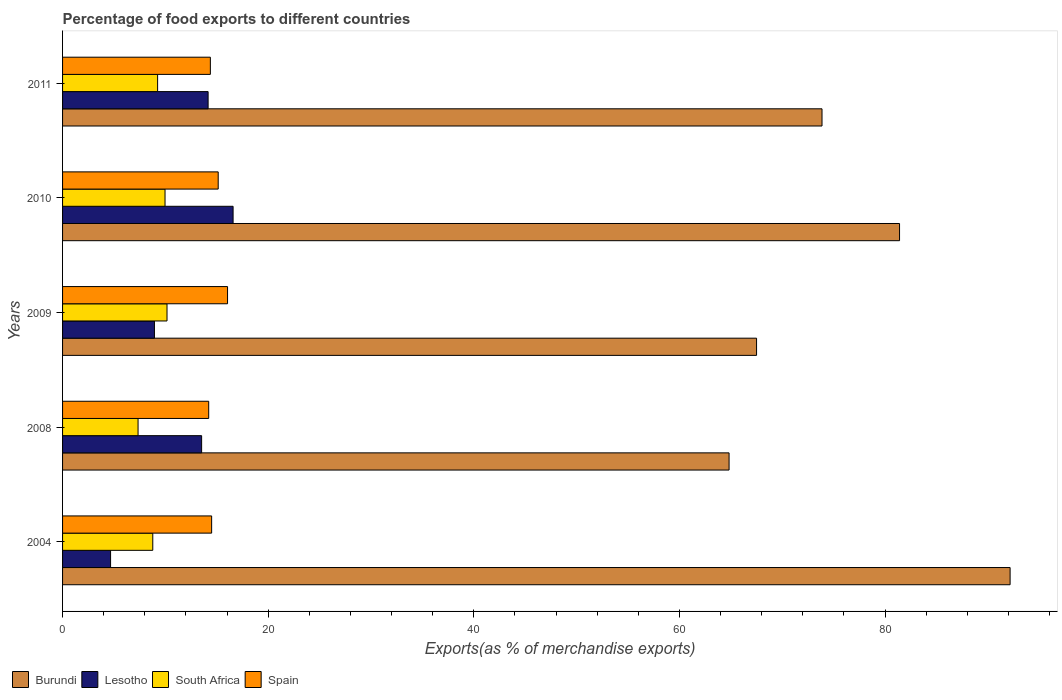How many different coloured bars are there?
Ensure brevity in your answer.  4. How many groups of bars are there?
Your response must be concise. 5. Are the number of bars per tick equal to the number of legend labels?
Give a very brief answer. Yes. Are the number of bars on each tick of the Y-axis equal?
Provide a short and direct response. Yes. How many bars are there on the 2nd tick from the top?
Provide a succinct answer. 4. What is the percentage of exports to different countries in South Africa in 2009?
Your response must be concise. 10.16. Across all years, what is the maximum percentage of exports to different countries in Burundi?
Ensure brevity in your answer.  92.16. Across all years, what is the minimum percentage of exports to different countries in Lesotho?
Your answer should be very brief. 4.67. In which year was the percentage of exports to different countries in Lesotho maximum?
Provide a succinct answer. 2010. In which year was the percentage of exports to different countries in Burundi minimum?
Keep it short and to the point. 2008. What is the total percentage of exports to different countries in Lesotho in the graph?
Give a very brief answer. 57.87. What is the difference between the percentage of exports to different countries in Lesotho in 2004 and that in 2009?
Make the answer very short. -4.27. What is the difference between the percentage of exports to different countries in Spain in 2004 and the percentage of exports to different countries in Burundi in 2008?
Keep it short and to the point. -50.33. What is the average percentage of exports to different countries in South Africa per year?
Offer a terse response. 9.1. In the year 2009, what is the difference between the percentage of exports to different countries in South Africa and percentage of exports to different countries in Lesotho?
Offer a terse response. 1.22. What is the ratio of the percentage of exports to different countries in South Africa in 2010 to that in 2011?
Make the answer very short. 1.08. Is the difference between the percentage of exports to different countries in South Africa in 2010 and 2011 greater than the difference between the percentage of exports to different countries in Lesotho in 2010 and 2011?
Provide a succinct answer. No. What is the difference between the highest and the second highest percentage of exports to different countries in Burundi?
Your answer should be compact. 10.75. What is the difference between the highest and the lowest percentage of exports to different countries in Spain?
Provide a succinct answer. 1.83. Is the sum of the percentage of exports to different countries in South Africa in 2004 and 2009 greater than the maximum percentage of exports to different countries in Burundi across all years?
Your answer should be very brief. No. What does the 2nd bar from the top in 2008 represents?
Give a very brief answer. South Africa. What does the 1st bar from the bottom in 2009 represents?
Ensure brevity in your answer.  Burundi. Is it the case that in every year, the sum of the percentage of exports to different countries in Lesotho and percentage of exports to different countries in Spain is greater than the percentage of exports to different countries in Burundi?
Keep it short and to the point. No. Are all the bars in the graph horizontal?
Give a very brief answer. Yes. How many years are there in the graph?
Ensure brevity in your answer.  5. Are the values on the major ticks of X-axis written in scientific E-notation?
Offer a terse response. No. Does the graph contain any zero values?
Make the answer very short. No. Does the graph contain grids?
Provide a short and direct response. No. How many legend labels are there?
Provide a short and direct response. 4. What is the title of the graph?
Your answer should be compact. Percentage of food exports to different countries. What is the label or title of the X-axis?
Your answer should be very brief. Exports(as % of merchandise exports). What is the Exports(as % of merchandise exports) of Burundi in 2004?
Provide a succinct answer. 92.16. What is the Exports(as % of merchandise exports) of Lesotho in 2004?
Offer a terse response. 4.67. What is the Exports(as % of merchandise exports) in South Africa in 2004?
Your response must be concise. 8.77. What is the Exports(as % of merchandise exports) of Spain in 2004?
Your answer should be very brief. 14.5. What is the Exports(as % of merchandise exports) in Burundi in 2008?
Ensure brevity in your answer.  64.83. What is the Exports(as % of merchandise exports) of Lesotho in 2008?
Keep it short and to the point. 13.52. What is the Exports(as % of merchandise exports) of South Africa in 2008?
Keep it short and to the point. 7.34. What is the Exports(as % of merchandise exports) of Spain in 2008?
Offer a very short reply. 14.21. What is the Exports(as % of merchandise exports) in Burundi in 2009?
Your response must be concise. 67.5. What is the Exports(as % of merchandise exports) of Lesotho in 2009?
Keep it short and to the point. 8.93. What is the Exports(as % of merchandise exports) in South Africa in 2009?
Ensure brevity in your answer.  10.16. What is the Exports(as % of merchandise exports) of Spain in 2009?
Keep it short and to the point. 16.05. What is the Exports(as % of merchandise exports) in Burundi in 2010?
Ensure brevity in your answer.  81.41. What is the Exports(as % of merchandise exports) of Lesotho in 2010?
Ensure brevity in your answer.  16.59. What is the Exports(as % of merchandise exports) in South Africa in 2010?
Ensure brevity in your answer.  9.97. What is the Exports(as % of merchandise exports) in Spain in 2010?
Provide a succinct answer. 15.14. What is the Exports(as % of merchandise exports) of Burundi in 2011?
Ensure brevity in your answer.  73.87. What is the Exports(as % of merchandise exports) of Lesotho in 2011?
Make the answer very short. 14.16. What is the Exports(as % of merchandise exports) in South Africa in 2011?
Your answer should be compact. 9.24. What is the Exports(as % of merchandise exports) of Spain in 2011?
Your response must be concise. 14.37. Across all years, what is the maximum Exports(as % of merchandise exports) in Burundi?
Make the answer very short. 92.16. Across all years, what is the maximum Exports(as % of merchandise exports) of Lesotho?
Ensure brevity in your answer.  16.59. Across all years, what is the maximum Exports(as % of merchandise exports) of South Africa?
Offer a very short reply. 10.16. Across all years, what is the maximum Exports(as % of merchandise exports) in Spain?
Your answer should be very brief. 16.05. Across all years, what is the minimum Exports(as % of merchandise exports) of Burundi?
Keep it short and to the point. 64.83. Across all years, what is the minimum Exports(as % of merchandise exports) of Lesotho?
Offer a terse response. 4.67. Across all years, what is the minimum Exports(as % of merchandise exports) of South Africa?
Your answer should be compact. 7.34. Across all years, what is the minimum Exports(as % of merchandise exports) of Spain?
Your response must be concise. 14.21. What is the total Exports(as % of merchandise exports) in Burundi in the graph?
Keep it short and to the point. 379.75. What is the total Exports(as % of merchandise exports) in Lesotho in the graph?
Provide a succinct answer. 57.87. What is the total Exports(as % of merchandise exports) of South Africa in the graph?
Keep it short and to the point. 45.49. What is the total Exports(as % of merchandise exports) of Spain in the graph?
Offer a terse response. 74.27. What is the difference between the Exports(as % of merchandise exports) of Burundi in 2004 and that in 2008?
Give a very brief answer. 27.33. What is the difference between the Exports(as % of merchandise exports) in Lesotho in 2004 and that in 2008?
Your answer should be very brief. -8.85. What is the difference between the Exports(as % of merchandise exports) of South Africa in 2004 and that in 2008?
Ensure brevity in your answer.  1.43. What is the difference between the Exports(as % of merchandise exports) of Spain in 2004 and that in 2008?
Make the answer very short. 0.29. What is the difference between the Exports(as % of merchandise exports) in Burundi in 2004 and that in 2009?
Your response must be concise. 24.66. What is the difference between the Exports(as % of merchandise exports) in Lesotho in 2004 and that in 2009?
Provide a short and direct response. -4.27. What is the difference between the Exports(as % of merchandise exports) of South Africa in 2004 and that in 2009?
Give a very brief answer. -1.38. What is the difference between the Exports(as % of merchandise exports) in Spain in 2004 and that in 2009?
Give a very brief answer. -1.55. What is the difference between the Exports(as % of merchandise exports) of Burundi in 2004 and that in 2010?
Your answer should be very brief. 10.75. What is the difference between the Exports(as % of merchandise exports) of Lesotho in 2004 and that in 2010?
Ensure brevity in your answer.  -11.92. What is the difference between the Exports(as % of merchandise exports) of South Africa in 2004 and that in 2010?
Offer a very short reply. -1.19. What is the difference between the Exports(as % of merchandise exports) in Spain in 2004 and that in 2010?
Make the answer very short. -0.64. What is the difference between the Exports(as % of merchandise exports) in Burundi in 2004 and that in 2011?
Offer a very short reply. 18.29. What is the difference between the Exports(as % of merchandise exports) in Lesotho in 2004 and that in 2011?
Your response must be concise. -9.49. What is the difference between the Exports(as % of merchandise exports) in South Africa in 2004 and that in 2011?
Your answer should be compact. -0.47. What is the difference between the Exports(as % of merchandise exports) in Spain in 2004 and that in 2011?
Keep it short and to the point. 0.12. What is the difference between the Exports(as % of merchandise exports) of Burundi in 2008 and that in 2009?
Give a very brief answer. -2.67. What is the difference between the Exports(as % of merchandise exports) of Lesotho in 2008 and that in 2009?
Your response must be concise. 4.59. What is the difference between the Exports(as % of merchandise exports) of South Africa in 2008 and that in 2009?
Provide a short and direct response. -2.82. What is the difference between the Exports(as % of merchandise exports) of Spain in 2008 and that in 2009?
Provide a short and direct response. -1.83. What is the difference between the Exports(as % of merchandise exports) of Burundi in 2008 and that in 2010?
Keep it short and to the point. -16.58. What is the difference between the Exports(as % of merchandise exports) in Lesotho in 2008 and that in 2010?
Keep it short and to the point. -3.06. What is the difference between the Exports(as % of merchandise exports) of South Africa in 2008 and that in 2010?
Your response must be concise. -2.62. What is the difference between the Exports(as % of merchandise exports) in Spain in 2008 and that in 2010?
Offer a terse response. -0.92. What is the difference between the Exports(as % of merchandise exports) in Burundi in 2008 and that in 2011?
Your response must be concise. -9.04. What is the difference between the Exports(as % of merchandise exports) of Lesotho in 2008 and that in 2011?
Offer a terse response. -0.63. What is the difference between the Exports(as % of merchandise exports) in South Africa in 2008 and that in 2011?
Make the answer very short. -1.9. What is the difference between the Exports(as % of merchandise exports) in Spain in 2008 and that in 2011?
Your answer should be very brief. -0.16. What is the difference between the Exports(as % of merchandise exports) of Burundi in 2009 and that in 2010?
Your answer should be compact. -13.91. What is the difference between the Exports(as % of merchandise exports) of Lesotho in 2009 and that in 2010?
Make the answer very short. -7.65. What is the difference between the Exports(as % of merchandise exports) in South Africa in 2009 and that in 2010?
Give a very brief answer. 0.19. What is the difference between the Exports(as % of merchandise exports) in Spain in 2009 and that in 2010?
Make the answer very short. 0.91. What is the difference between the Exports(as % of merchandise exports) of Burundi in 2009 and that in 2011?
Your answer should be compact. -6.37. What is the difference between the Exports(as % of merchandise exports) of Lesotho in 2009 and that in 2011?
Your answer should be compact. -5.22. What is the difference between the Exports(as % of merchandise exports) of South Africa in 2009 and that in 2011?
Offer a terse response. 0.91. What is the difference between the Exports(as % of merchandise exports) of Spain in 2009 and that in 2011?
Make the answer very short. 1.67. What is the difference between the Exports(as % of merchandise exports) in Burundi in 2010 and that in 2011?
Offer a terse response. 7.54. What is the difference between the Exports(as % of merchandise exports) of Lesotho in 2010 and that in 2011?
Provide a succinct answer. 2.43. What is the difference between the Exports(as % of merchandise exports) in South Africa in 2010 and that in 2011?
Make the answer very short. 0.72. What is the difference between the Exports(as % of merchandise exports) of Spain in 2010 and that in 2011?
Offer a terse response. 0.76. What is the difference between the Exports(as % of merchandise exports) in Burundi in 2004 and the Exports(as % of merchandise exports) in Lesotho in 2008?
Keep it short and to the point. 78.64. What is the difference between the Exports(as % of merchandise exports) in Burundi in 2004 and the Exports(as % of merchandise exports) in South Africa in 2008?
Your answer should be very brief. 84.82. What is the difference between the Exports(as % of merchandise exports) in Burundi in 2004 and the Exports(as % of merchandise exports) in Spain in 2008?
Provide a succinct answer. 77.95. What is the difference between the Exports(as % of merchandise exports) of Lesotho in 2004 and the Exports(as % of merchandise exports) of South Africa in 2008?
Make the answer very short. -2.67. What is the difference between the Exports(as % of merchandise exports) of Lesotho in 2004 and the Exports(as % of merchandise exports) of Spain in 2008?
Your answer should be compact. -9.54. What is the difference between the Exports(as % of merchandise exports) of South Africa in 2004 and the Exports(as % of merchandise exports) of Spain in 2008?
Provide a short and direct response. -5.44. What is the difference between the Exports(as % of merchandise exports) of Burundi in 2004 and the Exports(as % of merchandise exports) of Lesotho in 2009?
Ensure brevity in your answer.  83.22. What is the difference between the Exports(as % of merchandise exports) of Burundi in 2004 and the Exports(as % of merchandise exports) of South Africa in 2009?
Your response must be concise. 82. What is the difference between the Exports(as % of merchandise exports) of Burundi in 2004 and the Exports(as % of merchandise exports) of Spain in 2009?
Give a very brief answer. 76.11. What is the difference between the Exports(as % of merchandise exports) in Lesotho in 2004 and the Exports(as % of merchandise exports) in South Africa in 2009?
Give a very brief answer. -5.49. What is the difference between the Exports(as % of merchandise exports) of Lesotho in 2004 and the Exports(as % of merchandise exports) of Spain in 2009?
Ensure brevity in your answer.  -11.38. What is the difference between the Exports(as % of merchandise exports) of South Africa in 2004 and the Exports(as % of merchandise exports) of Spain in 2009?
Ensure brevity in your answer.  -7.27. What is the difference between the Exports(as % of merchandise exports) of Burundi in 2004 and the Exports(as % of merchandise exports) of Lesotho in 2010?
Your answer should be very brief. 75.57. What is the difference between the Exports(as % of merchandise exports) of Burundi in 2004 and the Exports(as % of merchandise exports) of South Africa in 2010?
Your answer should be compact. 82.19. What is the difference between the Exports(as % of merchandise exports) in Burundi in 2004 and the Exports(as % of merchandise exports) in Spain in 2010?
Provide a succinct answer. 77.02. What is the difference between the Exports(as % of merchandise exports) of Lesotho in 2004 and the Exports(as % of merchandise exports) of South Africa in 2010?
Your response must be concise. -5.3. What is the difference between the Exports(as % of merchandise exports) of Lesotho in 2004 and the Exports(as % of merchandise exports) of Spain in 2010?
Provide a succinct answer. -10.47. What is the difference between the Exports(as % of merchandise exports) in South Africa in 2004 and the Exports(as % of merchandise exports) in Spain in 2010?
Provide a short and direct response. -6.36. What is the difference between the Exports(as % of merchandise exports) of Burundi in 2004 and the Exports(as % of merchandise exports) of Lesotho in 2011?
Make the answer very short. 78. What is the difference between the Exports(as % of merchandise exports) in Burundi in 2004 and the Exports(as % of merchandise exports) in South Africa in 2011?
Your response must be concise. 82.92. What is the difference between the Exports(as % of merchandise exports) in Burundi in 2004 and the Exports(as % of merchandise exports) in Spain in 2011?
Your response must be concise. 77.79. What is the difference between the Exports(as % of merchandise exports) of Lesotho in 2004 and the Exports(as % of merchandise exports) of South Africa in 2011?
Offer a terse response. -4.57. What is the difference between the Exports(as % of merchandise exports) in Lesotho in 2004 and the Exports(as % of merchandise exports) in Spain in 2011?
Keep it short and to the point. -9.71. What is the difference between the Exports(as % of merchandise exports) of Burundi in 2008 and the Exports(as % of merchandise exports) of Lesotho in 2009?
Provide a short and direct response. 55.89. What is the difference between the Exports(as % of merchandise exports) in Burundi in 2008 and the Exports(as % of merchandise exports) in South Africa in 2009?
Offer a terse response. 54.67. What is the difference between the Exports(as % of merchandise exports) in Burundi in 2008 and the Exports(as % of merchandise exports) in Spain in 2009?
Give a very brief answer. 48.78. What is the difference between the Exports(as % of merchandise exports) in Lesotho in 2008 and the Exports(as % of merchandise exports) in South Africa in 2009?
Offer a very short reply. 3.37. What is the difference between the Exports(as % of merchandise exports) in Lesotho in 2008 and the Exports(as % of merchandise exports) in Spain in 2009?
Your answer should be very brief. -2.52. What is the difference between the Exports(as % of merchandise exports) in South Africa in 2008 and the Exports(as % of merchandise exports) in Spain in 2009?
Offer a very short reply. -8.7. What is the difference between the Exports(as % of merchandise exports) in Burundi in 2008 and the Exports(as % of merchandise exports) in Lesotho in 2010?
Ensure brevity in your answer.  48.24. What is the difference between the Exports(as % of merchandise exports) in Burundi in 2008 and the Exports(as % of merchandise exports) in South Africa in 2010?
Your answer should be very brief. 54.86. What is the difference between the Exports(as % of merchandise exports) in Burundi in 2008 and the Exports(as % of merchandise exports) in Spain in 2010?
Your response must be concise. 49.69. What is the difference between the Exports(as % of merchandise exports) of Lesotho in 2008 and the Exports(as % of merchandise exports) of South Africa in 2010?
Your answer should be compact. 3.56. What is the difference between the Exports(as % of merchandise exports) of Lesotho in 2008 and the Exports(as % of merchandise exports) of Spain in 2010?
Give a very brief answer. -1.61. What is the difference between the Exports(as % of merchandise exports) of South Africa in 2008 and the Exports(as % of merchandise exports) of Spain in 2010?
Keep it short and to the point. -7.79. What is the difference between the Exports(as % of merchandise exports) in Burundi in 2008 and the Exports(as % of merchandise exports) in Lesotho in 2011?
Your answer should be compact. 50.67. What is the difference between the Exports(as % of merchandise exports) of Burundi in 2008 and the Exports(as % of merchandise exports) of South Africa in 2011?
Your answer should be very brief. 55.58. What is the difference between the Exports(as % of merchandise exports) in Burundi in 2008 and the Exports(as % of merchandise exports) in Spain in 2011?
Provide a short and direct response. 50.45. What is the difference between the Exports(as % of merchandise exports) of Lesotho in 2008 and the Exports(as % of merchandise exports) of South Africa in 2011?
Your answer should be very brief. 4.28. What is the difference between the Exports(as % of merchandise exports) of Lesotho in 2008 and the Exports(as % of merchandise exports) of Spain in 2011?
Offer a terse response. -0.85. What is the difference between the Exports(as % of merchandise exports) of South Africa in 2008 and the Exports(as % of merchandise exports) of Spain in 2011?
Offer a very short reply. -7.03. What is the difference between the Exports(as % of merchandise exports) in Burundi in 2009 and the Exports(as % of merchandise exports) in Lesotho in 2010?
Give a very brief answer. 50.91. What is the difference between the Exports(as % of merchandise exports) in Burundi in 2009 and the Exports(as % of merchandise exports) in South Africa in 2010?
Provide a succinct answer. 57.53. What is the difference between the Exports(as % of merchandise exports) of Burundi in 2009 and the Exports(as % of merchandise exports) of Spain in 2010?
Your answer should be compact. 52.36. What is the difference between the Exports(as % of merchandise exports) in Lesotho in 2009 and the Exports(as % of merchandise exports) in South Africa in 2010?
Your answer should be compact. -1.03. What is the difference between the Exports(as % of merchandise exports) of Lesotho in 2009 and the Exports(as % of merchandise exports) of Spain in 2010?
Provide a succinct answer. -6.2. What is the difference between the Exports(as % of merchandise exports) of South Africa in 2009 and the Exports(as % of merchandise exports) of Spain in 2010?
Ensure brevity in your answer.  -4.98. What is the difference between the Exports(as % of merchandise exports) in Burundi in 2009 and the Exports(as % of merchandise exports) in Lesotho in 2011?
Provide a short and direct response. 53.34. What is the difference between the Exports(as % of merchandise exports) of Burundi in 2009 and the Exports(as % of merchandise exports) of South Africa in 2011?
Offer a very short reply. 58.25. What is the difference between the Exports(as % of merchandise exports) of Burundi in 2009 and the Exports(as % of merchandise exports) of Spain in 2011?
Your answer should be compact. 53.12. What is the difference between the Exports(as % of merchandise exports) of Lesotho in 2009 and the Exports(as % of merchandise exports) of South Africa in 2011?
Provide a succinct answer. -0.31. What is the difference between the Exports(as % of merchandise exports) in Lesotho in 2009 and the Exports(as % of merchandise exports) in Spain in 2011?
Keep it short and to the point. -5.44. What is the difference between the Exports(as % of merchandise exports) in South Africa in 2009 and the Exports(as % of merchandise exports) in Spain in 2011?
Offer a terse response. -4.22. What is the difference between the Exports(as % of merchandise exports) of Burundi in 2010 and the Exports(as % of merchandise exports) of Lesotho in 2011?
Provide a succinct answer. 67.25. What is the difference between the Exports(as % of merchandise exports) of Burundi in 2010 and the Exports(as % of merchandise exports) of South Africa in 2011?
Make the answer very short. 72.16. What is the difference between the Exports(as % of merchandise exports) in Burundi in 2010 and the Exports(as % of merchandise exports) in Spain in 2011?
Your response must be concise. 67.03. What is the difference between the Exports(as % of merchandise exports) of Lesotho in 2010 and the Exports(as % of merchandise exports) of South Africa in 2011?
Your answer should be very brief. 7.34. What is the difference between the Exports(as % of merchandise exports) of Lesotho in 2010 and the Exports(as % of merchandise exports) of Spain in 2011?
Ensure brevity in your answer.  2.21. What is the difference between the Exports(as % of merchandise exports) of South Africa in 2010 and the Exports(as % of merchandise exports) of Spain in 2011?
Ensure brevity in your answer.  -4.41. What is the average Exports(as % of merchandise exports) of Burundi per year?
Offer a very short reply. 75.95. What is the average Exports(as % of merchandise exports) of Lesotho per year?
Ensure brevity in your answer.  11.57. What is the average Exports(as % of merchandise exports) of South Africa per year?
Your answer should be very brief. 9.1. What is the average Exports(as % of merchandise exports) in Spain per year?
Offer a terse response. 14.85. In the year 2004, what is the difference between the Exports(as % of merchandise exports) of Burundi and Exports(as % of merchandise exports) of Lesotho?
Offer a very short reply. 87.49. In the year 2004, what is the difference between the Exports(as % of merchandise exports) in Burundi and Exports(as % of merchandise exports) in South Africa?
Offer a very short reply. 83.39. In the year 2004, what is the difference between the Exports(as % of merchandise exports) in Burundi and Exports(as % of merchandise exports) in Spain?
Your answer should be compact. 77.66. In the year 2004, what is the difference between the Exports(as % of merchandise exports) of Lesotho and Exports(as % of merchandise exports) of South Africa?
Offer a terse response. -4.11. In the year 2004, what is the difference between the Exports(as % of merchandise exports) of Lesotho and Exports(as % of merchandise exports) of Spain?
Your answer should be very brief. -9.83. In the year 2004, what is the difference between the Exports(as % of merchandise exports) of South Africa and Exports(as % of merchandise exports) of Spain?
Provide a short and direct response. -5.72. In the year 2008, what is the difference between the Exports(as % of merchandise exports) of Burundi and Exports(as % of merchandise exports) of Lesotho?
Your answer should be compact. 51.3. In the year 2008, what is the difference between the Exports(as % of merchandise exports) of Burundi and Exports(as % of merchandise exports) of South Africa?
Provide a short and direct response. 57.48. In the year 2008, what is the difference between the Exports(as % of merchandise exports) of Burundi and Exports(as % of merchandise exports) of Spain?
Offer a terse response. 50.61. In the year 2008, what is the difference between the Exports(as % of merchandise exports) in Lesotho and Exports(as % of merchandise exports) in South Africa?
Your response must be concise. 6.18. In the year 2008, what is the difference between the Exports(as % of merchandise exports) in Lesotho and Exports(as % of merchandise exports) in Spain?
Offer a very short reply. -0.69. In the year 2008, what is the difference between the Exports(as % of merchandise exports) of South Africa and Exports(as % of merchandise exports) of Spain?
Keep it short and to the point. -6.87. In the year 2009, what is the difference between the Exports(as % of merchandise exports) in Burundi and Exports(as % of merchandise exports) in Lesotho?
Make the answer very short. 58.56. In the year 2009, what is the difference between the Exports(as % of merchandise exports) in Burundi and Exports(as % of merchandise exports) in South Africa?
Your response must be concise. 57.34. In the year 2009, what is the difference between the Exports(as % of merchandise exports) of Burundi and Exports(as % of merchandise exports) of Spain?
Provide a succinct answer. 51.45. In the year 2009, what is the difference between the Exports(as % of merchandise exports) of Lesotho and Exports(as % of merchandise exports) of South Africa?
Your answer should be compact. -1.22. In the year 2009, what is the difference between the Exports(as % of merchandise exports) of Lesotho and Exports(as % of merchandise exports) of Spain?
Your answer should be very brief. -7.11. In the year 2009, what is the difference between the Exports(as % of merchandise exports) in South Africa and Exports(as % of merchandise exports) in Spain?
Ensure brevity in your answer.  -5.89. In the year 2010, what is the difference between the Exports(as % of merchandise exports) of Burundi and Exports(as % of merchandise exports) of Lesotho?
Keep it short and to the point. 64.82. In the year 2010, what is the difference between the Exports(as % of merchandise exports) in Burundi and Exports(as % of merchandise exports) in South Africa?
Your response must be concise. 71.44. In the year 2010, what is the difference between the Exports(as % of merchandise exports) of Burundi and Exports(as % of merchandise exports) of Spain?
Ensure brevity in your answer.  66.27. In the year 2010, what is the difference between the Exports(as % of merchandise exports) of Lesotho and Exports(as % of merchandise exports) of South Africa?
Make the answer very short. 6.62. In the year 2010, what is the difference between the Exports(as % of merchandise exports) of Lesotho and Exports(as % of merchandise exports) of Spain?
Give a very brief answer. 1.45. In the year 2010, what is the difference between the Exports(as % of merchandise exports) of South Africa and Exports(as % of merchandise exports) of Spain?
Offer a very short reply. -5.17. In the year 2011, what is the difference between the Exports(as % of merchandise exports) of Burundi and Exports(as % of merchandise exports) of Lesotho?
Keep it short and to the point. 59.71. In the year 2011, what is the difference between the Exports(as % of merchandise exports) in Burundi and Exports(as % of merchandise exports) in South Africa?
Offer a very short reply. 64.62. In the year 2011, what is the difference between the Exports(as % of merchandise exports) in Burundi and Exports(as % of merchandise exports) in Spain?
Keep it short and to the point. 59.49. In the year 2011, what is the difference between the Exports(as % of merchandise exports) of Lesotho and Exports(as % of merchandise exports) of South Africa?
Provide a succinct answer. 4.91. In the year 2011, what is the difference between the Exports(as % of merchandise exports) of Lesotho and Exports(as % of merchandise exports) of Spain?
Provide a succinct answer. -0.22. In the year 2011, what is the difference between the Exports(as % of merchandise exports) in South Africa and Exports(as % of merchandise exports) in Spain?
Make the answer very short. -5.13. What is the ratio of the Exports(as % of merchandise exports) in Burundi in 2004 to that in 2008?
Make the answer very short. 1.42. What is the ratio of the Exports(as % of merchandise exports) of Lesotho in 2004 to that in 2008?
Your response must be concise. 0.35. What is the ratio of the Exports(as % of merchandise exports) of South Africa in 2004 to that in 2008?
Your answer should be compact. 1.2. What is the ratio of the Exports(as % of merchandise exports) of Spain in 2004 to that in 2008?
Keep it short and to the point. 1.02. What is the ratio of the Exports(as % of merchandise exports) in Burundi in 2004 to that in 2009?
Give a very brief answer. 1.37. What is the ratio of the Exports(as % of merchandise exports) in Lesotho in 2004 to that in 2009?
Give a very brief answer. 0.52. What is the ratio of the Exports(as % of merchandise exports) in South Africa in 2004 to that in 2009?
Your answer should be very brief. 0.86. What is the ratio of the Exports(as % of merchandise exports) in Spain in 2004 to that in 2009?
Ensure brevity in your answer.  0.9. What is the ratio of the Exports(as % of merchandise exports) in Burundi in 2004 to that in 2010?
Provide a short and direct response. 1.13. What is the ratio of the Exports(as % of merchandise exports) of Lesotho in 2004 to that in 2010?
Keep it short and to the point. 0.28. What is the ratio of the Exports(as % of merchandise exports) of South Africa in 2004 to that in 2010?
Your answer should be very brief. 0.88. What is the ratio of the Exports(as % of merchandise exports) of Spain in 2004 to that in 2010?
Offer a very short reply. 0.96. What is the ratio of the Exports(as % of merchandise exports) of Burundi in 2004 to that in 2011?
Your answer should be very brief. 1.25. What is the ratio of the Exports(as % of merchandise exports) in Lesotho in 2004 to that in 2011?
Your answer should be very brief. 0.33. What is the ratio of the Exports(as % of merchandise exports) of South Africa in 2004 to that in 2011?
Keep it short and to the point. 0.95. What is the ratio of the Exports(as % of merchandise exports) of Spain in 2004 to that in 2011?
Your answer should be very brief. 1.01. What is the ratio of the Exports(as % of merchandise exports) of Burundi in 2008 to that in 2009?
Your answer should be very brief. 0.96. What is the ratio of the Exports(as % of merchandise exports) in Lesotho in 2008 to that in 2009?
Your answer should be compact. 1.51. What is the ratio of the Exports(as % of merchandise exports) in South Africa in 2008 to that in 2009?
Your answer should be very brief. 0.72. What is the ratio of the Exports(as % of merchandise exports) in Spain in 2008 to that in 2009?
Provide a short and direct response. 0.89. What is the ratio of the Exports(as % of merchandise exports) of Burundi in 2008 to that in 2010?
Ensure brevity in your answer.  0.8. What is the ratio of the Exports(as % of merchandise exports) in Lesotho in 2008 to that in 2010?
Ensure brevity in your answer.  0.82. What is the ratio of the Exports(as % of merchandise exports) in South Africa in 2008 to that in 2010?
Give a very brief answer. 0.74. What is the ratio of the Exports(as % of merchandise exports) in Spain in 2008 to that in 2010?
Keep it short and to the point. 0.94. What is the ratio of the Exports(as % of merchandise exports) of Burundi in 2008 to that in 2011?
Keep it short and to the point. 0.88. What is the ratio of the Exports(as % of merchandise exports) in Lesotho in 2008 to that in 2011?
Your answer should be compact. 0.96. What is the ratio of the Exports(as % of merchandise exports) in South Africa in 2008 to that in 2011?
Give a very brief answer. 0.79. What is the ratio of the Exports(as % of merchandise exports) in Burundi in 2009 to that in 2010?
Provide a short and direct response. 0.83. What is the ratio of the Exports(as % of merchandise exports) of Lesotho in 2009 to that in 2010?
Ensure brevity in your answer.  0.54. What is the ratio of the Exports(as % of merchandise exports) of South Africa in 2009 to that in 2010?
Give a very brief answer. 1.02. What is the ratio of the Exports(as % of merchandise exports) in Spain in 2009 to that in 2010?
Ensure brevity in your answer.  1.06. What is the ratio of the Exports(as % of merchandise exports) of Burundi in 2009 to that in 2011?
Your answer should be compact. 0.91. What is the ratio of the Exports(as % of merchandise exports) in Lesotho in 2009 to that in 2011?
Offer a terse response. 0.63. What is the ratio of the Exports(as % of merchandise exports) in South Africa in 2009 to that in 2011?
Provide a succinct answer. 1.1. What is the ratio of the Exports(as % of merchandise exports) of Spain in 2009 to that in 2011?
Your response must be concise. 1.12. What is the ratio of the Exports(as % of merchandise exports) in Burundi in 2010 to that in 2011?
Give a very brief answer. 1.1. What is the ratio of the Exports(as % of merchandise exports) in Lesotho in 2010 to that in 2011?
Offer a very short reply. 1.17. What is the ratio of the Exports(as % of merchandise exports) in South Africa in 2010 to that in 2011?
Provide a succinct answer. 1.08. What is the ratio of the Exports(as % of merchandise exports) in Spain in 2010 to that in 2011?
Provide a succinct answer. 1.05. What is the difference between the highest and the second highest Exports(as % of merchandise exports) in Burundi?
Give a very brief answer. 10.75. What is the difference between the highest and the second highest Exports(as % of merchandise exports) of Lesotho?
Your answer should be compact. 2.43. What is the difference between the highest and the second highest Exports(as % of merchandise exports) in South Africa?
Give a very brief answer. 0.19. What is the difference between the highest and the second highest Exports(as % of merchandise exports) of Spain?
Offer a terse response. 0.91. What is the difference between the highest and the lowest Exports(as % of merchandise exports) in Burundi?
Offer a very short reply. 27.33. What is the difference between the highest and the lowest Exports(as % of merchandise exports) of Lesotho?
Ensure brevity in your answer.  11.92. What is the difference between the highest and the lowest Exports(as % of merchandise exports) of South Africa?
Make the answer very short. 2.82. What is the difference between the highest and the lowest Exports(as % of merchandise exports) of Spain?
Offer a very short reply. 1.83. 